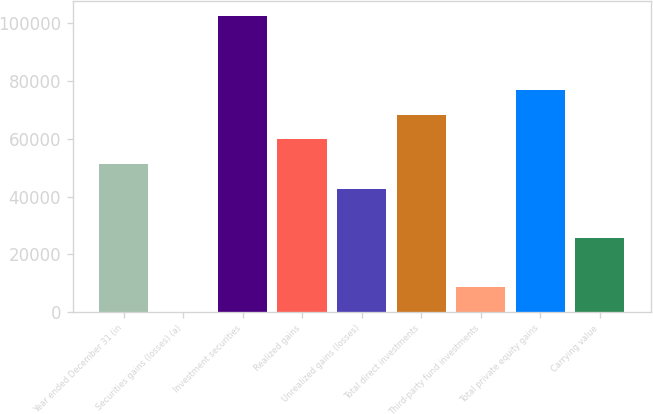Convert chart. <chart><loc_0><loc_0><loc_500><loc_500><bar_chart><fcel>Year ended December 31 (in<fcel>Securities gains (losses) (a)<fcel>Investment securities<fcel>Realized gains<fcel>Unrealized gains (losses)<fcel>Total direct investments<fcel>Third-party fund investments<fcel>Total private equity gains<fcel>Carrying value<nl><fcel>51325<fcel>37<fcel>102613<fcel>59873<fcel>42777<fcel>68421<fcel>8585<fcel>76969<fcel>25681<nl></chart> 